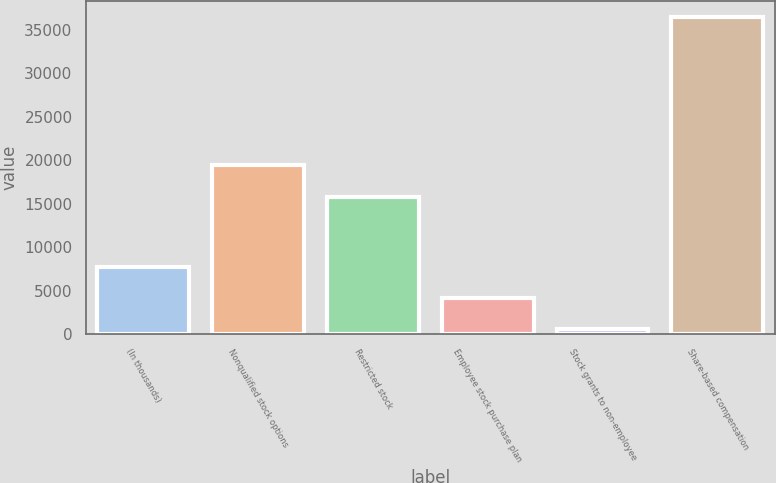Convert chart. <chart><loc_0><loc_0><loc_500><loc_500><bar_chart><fcel>(In thousands)<fcel>Nonqualified stock options<fcel>Restricted stock<fcel>Employee stock purchase plan<fcel>Stock grants to non-employee<fcel>Share-based compensation<nl><fcel>7770<fcel>19416.5<fcel>15823<fcel>4176.5<fcel>583<fcel>36518<nl></chart> 